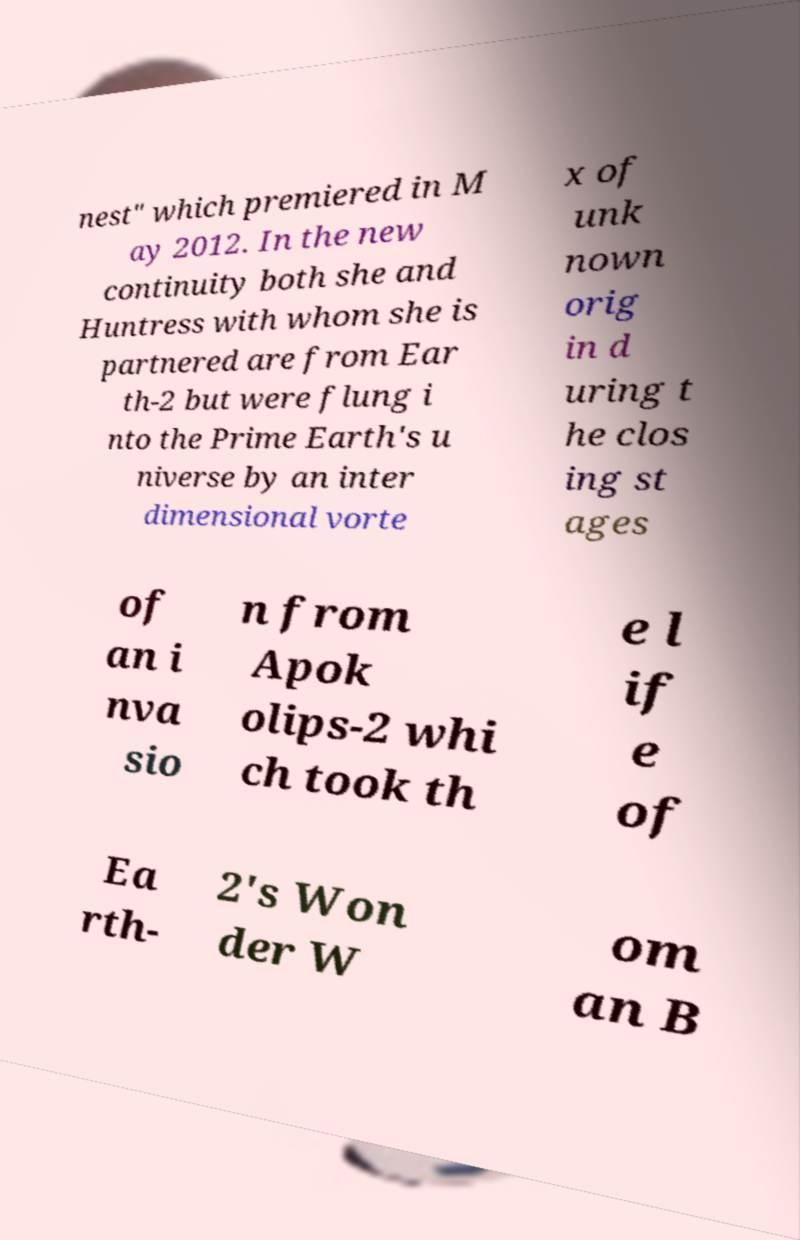There's text embedded in this image that I need extracted. Can you transcribe it verbatim? nest" which premiered in M ay 2012. In the new continuity both she and Huntress with whom she is partnered are from Ear th-2 but were flung i nto the Prime Earth's u niverse by an inter dimensional vorte x of unk nown orig in d uring t he clos ing st ages of an i nva sio n from Apok olips-2 whi ch took th e l if e of Ea rth- 2's Won der W om an B 